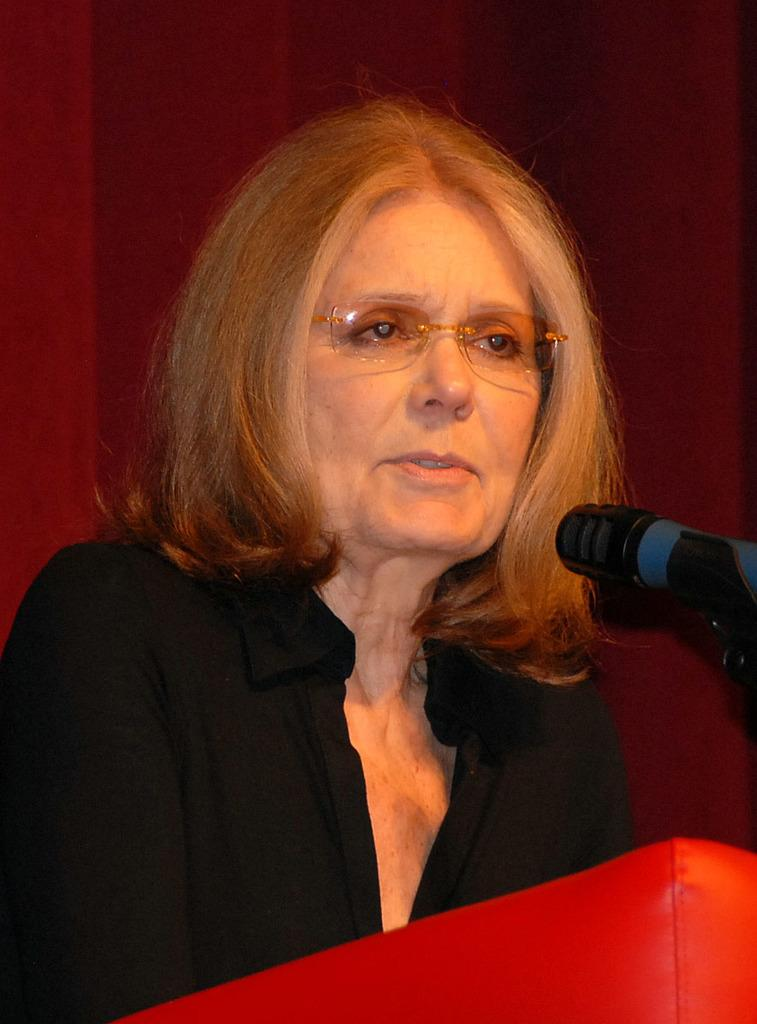Who is the main subject in the image? There is a woman in the image. What is the woman doing in the image? The woman is talking in the image. What is the woman using to amplify her voice? There are microphones on the podium in the image. What can be seen in the background of the image? There is a curtain visible in the background of the image. What type of sail can be seen in the image? There is no sail present in the image; it features a woman behind a podium. How does the woman roll the paper while talking in the image? The woman is not rolling any paper while talking in the image; she is simply speaking into the microphones. 